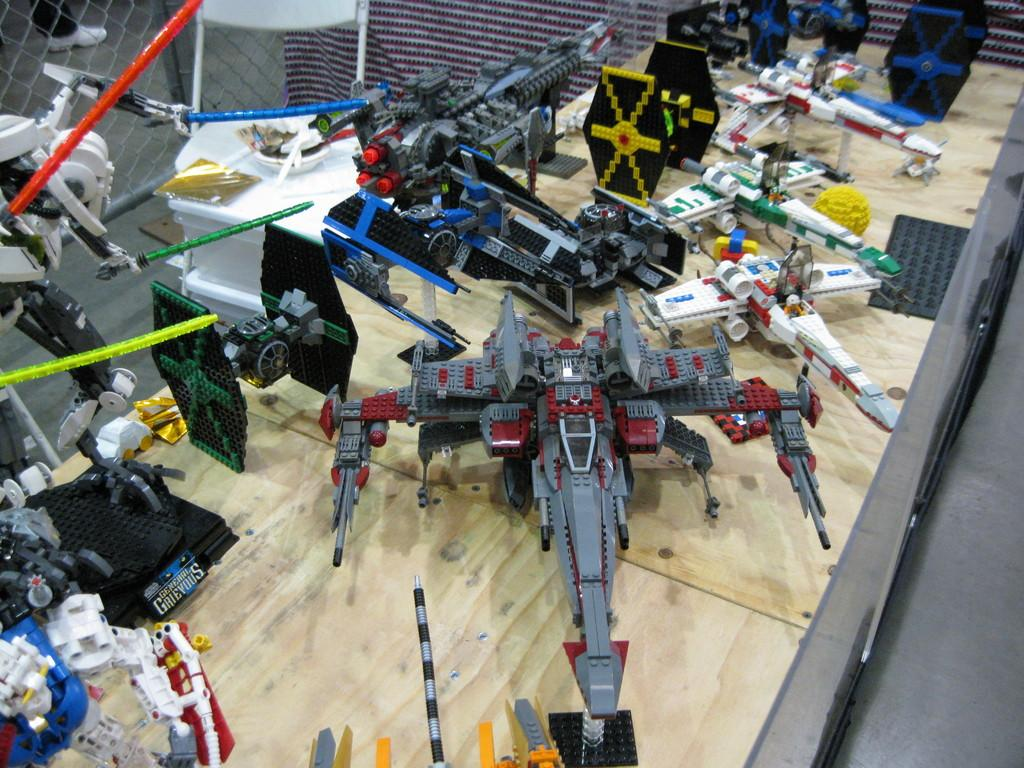What is at the bottom of the image? There is a wooden board at the bottom of the image. What is placed on the wooden board? There are toys and building blocks on the wooden board. What can be seen in the background of the image? There is a chair, a curtain, and a net in the background of the image. What type of card is being used to cause the toys to levitate in the image? There is no card or levitation of toys present in the image. 